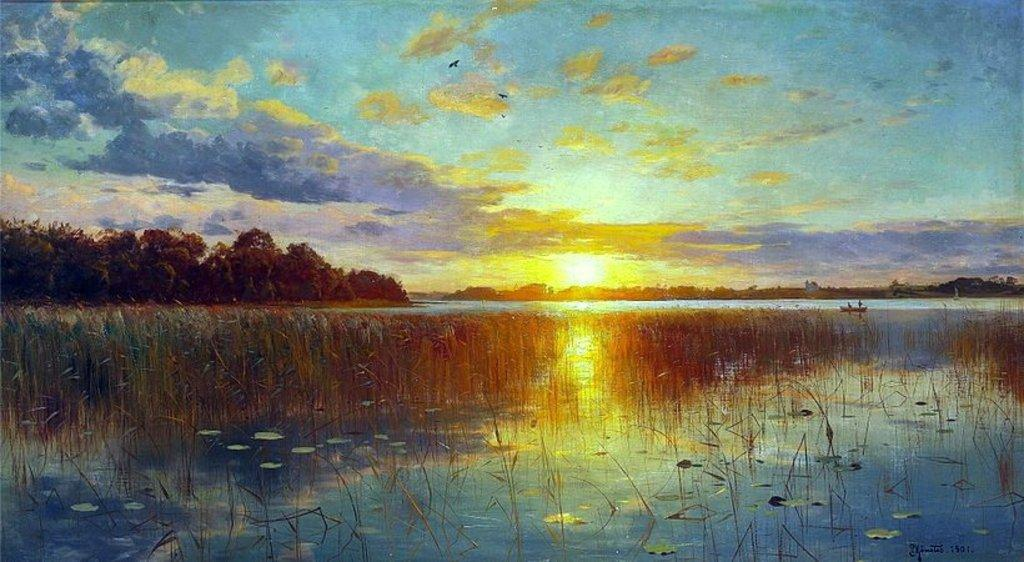What type of artwork is depicted in the image? The image appears to be a painting. What is happening in the water in the painting? There are plants in the water and a boat on the water. What can be seen in the background of the painting? There are trees and the sky visible in the background. Is there any text present in the image? Yes, there is text written on the image. What type of amusement park ride is featured in the painting? There is no amusement park ride present in the painting; it features plants, a boat, trees, and the sky. 